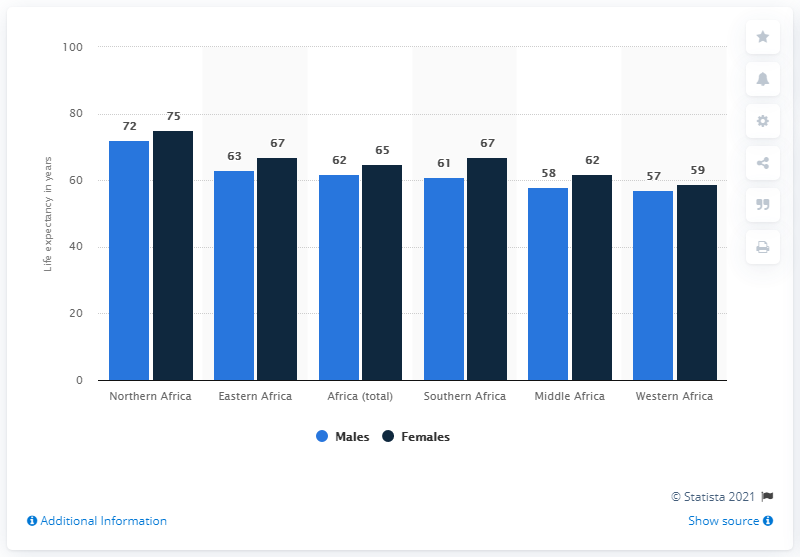Give some essential details in this illustration. What is the result of adding the two tallest blue bars? According to predictions, in Northern Africa, both male and female babies born in 2020 are expected to live longer than in any other region in Africa. 